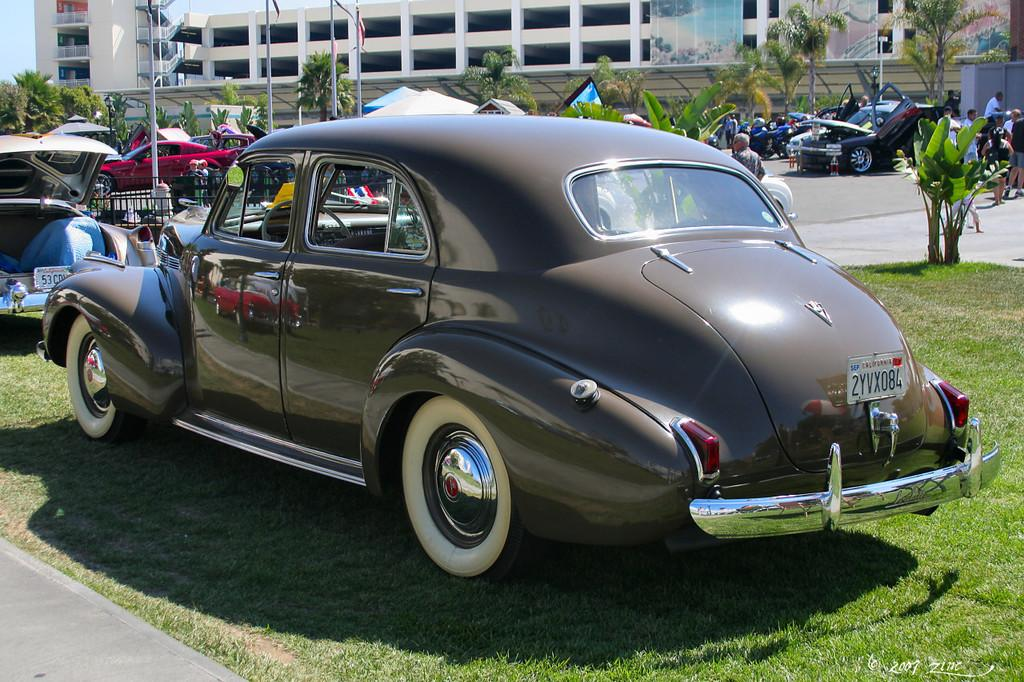What is the main subject in the center of the image? There is a car in the center of the image. Where is the car located? The car is on the grass. What can be seen in the background of the image? There are cars, trees, and buildings visible in the background of the image. What is to the left side of the image? There is a road to the left side of the image. Where is the tray located in the image? There is no tray present in the image. What type of cannon is visible in the background of the image? There is no cannon present in the image. 